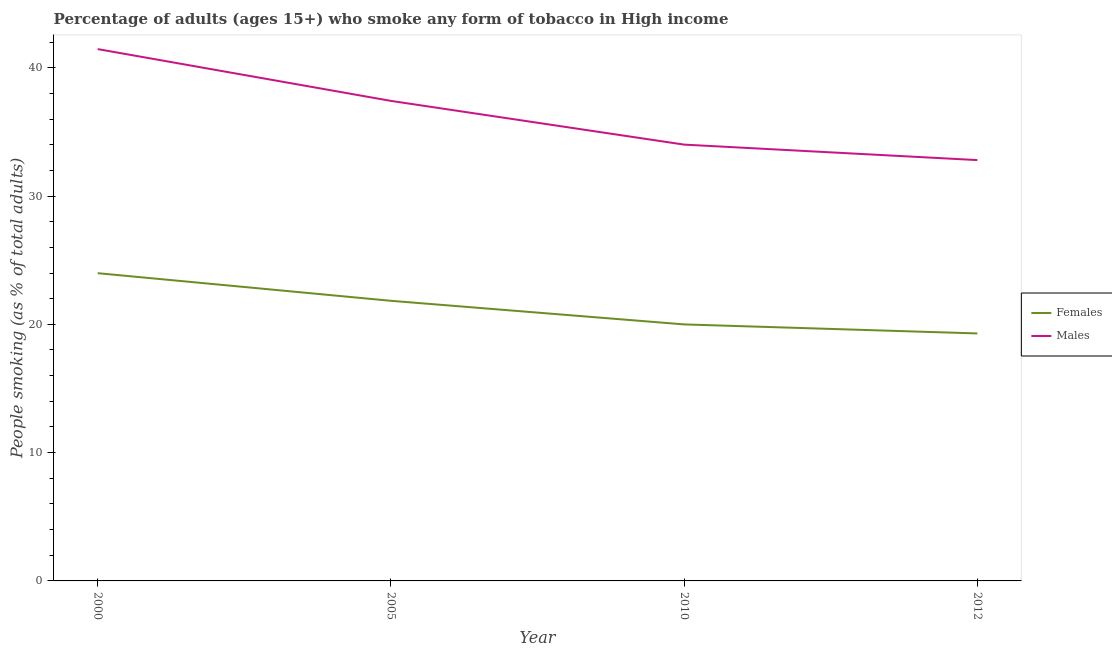Does the line corresponding to percentage of males who smoke intersect with the line corresponding to percentage of females who smoke?
Your answer should be very brief. No. What is the percentage of females who smoke in 2000?
Your response must be concise. 23.99. Across all years, what is the maximum percentage of females who smoke?
Your answer should be very brief. 23.99. Across all years, what is the minimum percentage of females who smoke?
Offer a very short reply. 19.29. In which year was the percentage of females who smoke minimum?
Provide a short and direct response. 2012. What is the total percentage of females who smoke in the graph?
Provide a succinct answer. 85.11. What is the difference between the percentage of males who smoke in 2005 and that in 2012?
Your answer should be very brief. 4.61. What is the difference between the percentage of females who smoke in 2010 and the percentage of males who smoke in 2000?
Ensure brevity in your answer.  -21.46. What is the average percentage of females who smoke per year?
Keep it short and to the point. 21.28. In the year 2005, what is the difference between the percentage of males who smoke and percentage of females who smoke?
Give a very brief answer. 15.58. What is the ratio of the percentage of males who smoke in 2005 to that in 2010?
Your response must be concise. 1.1. Is the percentage of females who smoke in 2005 less than that in 2012?
Offer a terse response. No. Is the difference between the percentage of males who smoke in 2000 and 2005 greater than the difference between the percentage of females who smoke in 2000 and 2005?
Keep it short and to the point. Yes. What is the difference between the highest and the second highest percentage of males who smoke?
Offer a very short reply. 4.04. What is the difference between the highest and the lowest percentage of females who smoke?
Your answer should be very brief. 4.7. In how many years, is the percentage of males who smoke greater than the average percentage of males who smoke taken over all years?
Keep it short and to the point. 2. Is the percentage of males who smoke strictly greater than the percentage of females who smoke over the years?
Provide a succinct answer. Yes. Is the percentage of females who smoke strictly less than the percentage of males who smoke over the years?
Make the answer very short. Yes. Are the values on the major ticks of Y-axis written in scientific E-notation?
Your response must be concise. No. Where does the legend appear in the graph?
Keep it short and to the point. Center right. How are the legend labels stacked?
Your response must be concise. Vertical. What is the title of the graph?
Provide a short and direct response. Percentage of adults (ages 15+) who smoke any form of tobacco in High income. What is the label or title of the Y-axis?
Offer a terse response. People smoking (as % of total adults). What is the People smoking (as % of total adults) in Females in 2000?
Offer a terse response. 23.99. What is the People smoking (as % of total adults) of Males in 2000?
Offer a terse response. 41.45. What is the People smoking (as % of total adults) in Females in 2005?
Your response must be concise. 21.83. What is the People smoking (as % of total adults) of Males in 2005?
Ensure brevity in your answer.  37.42. What is the People smoking (as % of total adults) in Females in 2010?
Provide a succinct answer. 19.99. What is the People smoking (as % of total adults) in Males in 2010?
Make the answer very short. 34.01. What is the People smoking (as % of total adults) of Females in 2012?
Your answer should be compact. 19.29. What is the People smoking (as % of total adults) in Males in 2012?
Your answer should be very brief. 32.8. Across all years, what is the maximum People smoking (as % of total adults) of Females?
Make the answer very short. 23.99. Across all years, what is the maximum People smoking (as % of total adults) in Males?
Give a very brief answer. 41.45. Across all years, what is the minimum People smoking (as % of total adults) in Females?
Your response must be concise. 19.29. Across all years, what is the minimum People smoking (as % of total adults) in Males?
Offer a terse response. 32.8. What is the total People smoking (as % of total adults) of Females in the graph?
Ensure brevity in your answer.  85.11. What is the total People smoking (as % of total adults) in Males in the graph?
Make the answer very short. 145.68. What is the difference between the People smoking (as % of total adults) in Females in 2000 and that in 2005?
Offer a very short reply. 2.15. What is the difference between the People smoking (as % of total adults) of Males in 2000 and that in 2005?
Provide a succinct answer. 4.04. What is the difference between the People smoking (as % of total adults) in Females in 2000 and that in 2010?
Your answer should be compact. 3.99. What is the difference between the People smoking (as % of total adults) in Males in 2000 and that in 2010?
Give a very brief answer. 7.45. What is the difference between the People smoking (as % of total adults) in Females in 2000 and that in 2012?
Keep it short and to the point. 4.7. What is the difference between the People smoking (as % of total adults) of Males in 2000 and that in 2012?
Your answer should be compact. 8.65. What is the difference between the People smoking (as % of total adults) of Females in 2005 and that in 2010?
Keep it short and to the point. 1.84. What is the difference between the People smoking (as % of total adults) of Males in 2005 and that in 2010?
Give a very brief answer. 3.41. What is the difference between the People smoking (as % of total adults) of Females in 2005 and that in 2012?
Offer a terse response. 2.54. What is the difference between the People smoking (as % of total adults) of Males in 2005 and that in 2012?
Offer a very short reply. 4.61. What is the difference between the People smoking (as % of total adults) of Females in 2010 and that in 2012?
Make the answer very short. 0.7. What is the difference between the People smoking (as % of total adults) of Males in 2010 and that in 2012?
Keep it short and to the point. 1.21. What is the difference between the People smoking (as % of total adults) of Females in 2000 and the People smoking (as % of total adults) of Males in 2005?
Provide a short and direct response. -13.43. What is the difference between the People smoking (as % of total adults) in Females in 2000 and the People smoking (as % of total adults) in Males in 2010?
Ensure brevity in your answer.  -10.02. What is the difference between the People smoking (as % of total adults) in Females in 2000 and the People smoking (as % of total adults) in Males in 2012?
Provide a succinct answer. -8.81. What is the difference between the People smoking (as % of total adults) in Females in 2005 and the People smoking (as % of total adults) in Males in 2010?
Your answer should be very brief. -12.17. What is the difference between the People smoking (as % of total adults) in Females in 2005 and the People smoking (as % of total adults) in Males in 2012?
Keep it short and to the point. -10.97. What is the difference between the People smoking (as % of total adults) of Females in 2010 and the People smoking (as % of total adults) of Males in 2012?
Provide a short and direct response. -12.81. What is the average People smoking (as % of total adults) of Females per year?
Provide a succinct answer. 21.28. What is the average People smoking (as % of total adults) of Males per year?
Keep it short and to the point. 36.42. In the year 2000, what is the difference between the People smoking (as % of total adults) in Females and People smoking (as % of total adults) in Males?
Provide a short and direct response. -17.47. In the year 2005, what is the difference between the People smoking (as % of total adults) of Females and People smoking (as % of total adults) of Males?
Make the answer very short. -15.58. In the year 2010, what is the difference between the People smoking (as % of total adults) in Females and People smoking (as % of total adults) in Males?
Keep it short and to the point. -14.01. In the year 2012, what is the difference between the People smoking (as % of total adults) in Females and People smoking (as % of total adults) in Males?
Provide a short and direct response. -13.51. What is the ratio of the People smoking (as % of total adults) in Females in 2000 to that in 2005?
Ensure brevity in your answer.  1.1. What is the ratio of the People smoking (as % of total adults) of Males in 2000 to that in 2005?
Offer a terse response. 1.11. What is the ratio of the People smoking (as % of total adults) of Females in 2000 to that in 2010?
Provide a short and direct response. 1.2. What is the ratio of the People smoking (as % of total adults) of Males in 2000 to that in 2010?
Your answer should be very brief. 1.22. What is the ratio of the People smoking (as % of total adults) in Females in 2000 to that in 2012?
Your answer should be very brief. 1.24. What is the ratio of the People smoking (as % of total adults) of Males in 2000 to that in 2012?
Ensure brevity in your answer.  1.26. What is the ratio of the People smoking (as % of total adults) of Females in 2005 to that in 2010?
Your answer should be very brief. 1.09. What is the ratio of the People smoking (as % of total adults) of Males in 2005 to that in 2010?
Offer a terse response. 1.1. What is the ratio of the People smoking (as % of total adults) of Females in 2005 to that in 2012?
Your answer should be very brief. 1.13. What is the ratio of the People smoking (as % of total adults) in Males in 2005 to that in 2012?
Offer a very short reply. 1.14. What is the ratio of the People smoking (as % of total adults) in Females in 2010 to that in 2012?
Give a very brief answer. 1.04. What is the ratio of the People smoking (as % of total adults) of Males in 2010 to that in 2012?
Offer a terse response. 1.04. What is the difference between the highest and the second highest People smoking (as % of total adults) in Females?
Your response must be concise. 2.15. What is the difference between the highest and the second highest People smoking (as % of total adults) of Males?
Your answer should be compact. 4.04. What is the difference between the highest and the lowest People smoking (as % of total adults) in Females?
Offer a terse response. 4.7. What is the difference between the highest and the lowest People smoking (as % of total adults) in Males?
Ensure brevity in your answer.  8.65. 